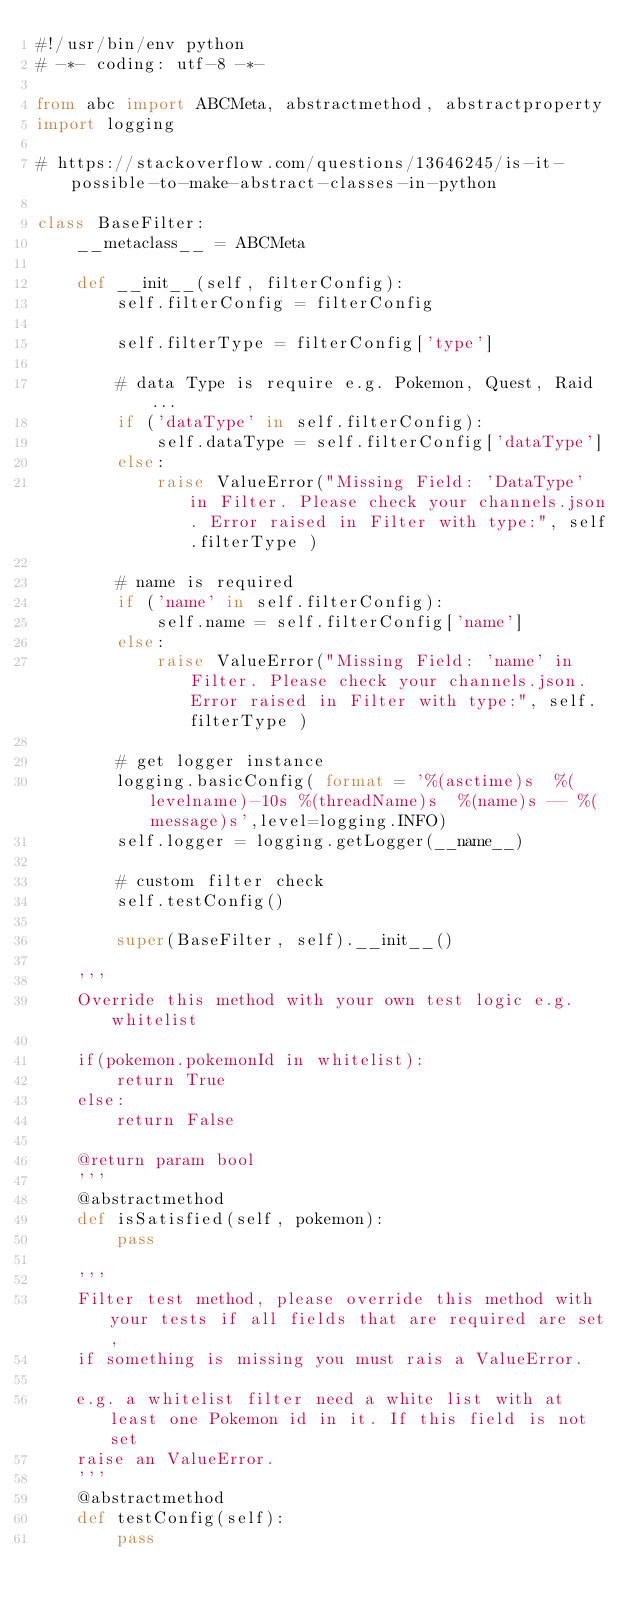Convert code to text. <code><loc_0><loc_0><loc_500><loc_500><_Python_>#!/usr/bin/env python
# -*- coding: utf-8 -*-

from abc import ABCMeta, abstractmethod, abstractproperty
import logging

# https://stackoverflow.com/questions/13646245/is-it-possible-to-make-abstract-classes-in-python

class BaseFilter:
    __metaclass__ = ABCMeta

    def __init__(self, filterConfig):
        self.filterConfig = filterConfig
        
        self.filterType = filterConfig['type']

        # data Type is require e.g. Pokemon, Quest, Raid ...
        if ('dataType' in self.filterConfig):
            self.dataType = self.filterConfig['dataType']
        else:
            raise ValueError("Missing Field: 'DataType' in Filter. Please check your channels.json. Error raised in Filter with type:", self.filterType )

        # name is required
        if ('name' in self.filterConfig):
            self.name = self.filterConfig['name']
        else:
            raise ValueError("Missing Field: 'name' in Filter. Please check your channels.json. Error raised in Filter with type:", self.filterType )
        
        # get logger instance
        logging.basicConfig( format = '%(asctime)s  %(levelname)-10s %(threadName)s  %(name)s -- %(message)s',level=logging.INFO)
        self.logger = logging.getLogger(__name__)

        # custom filter check
        self.testConfig()

        super(BaseFilter, self).__init__()

    '''
    Override this method with your own test logic e.g. whitelist 

    if(pokemon.pokemonId in whitelist):
        return True
    else:
        return False

    @return param bool
    '''
    @abstractmethod
    def isSatisfied(self, pokemon):
        pass
    
    '''
    Filter test method, please override this method with your tests if all fields that are required are set,
    if something is missing you must rais a ValueError.

    e.g. a whitelist filter need a white list with at least one Pokemon id in it. If this field is not set 
    raise an ValueError.
    '''
    @abstractmethod
    def testConfig(self):
        pass    
</code> 